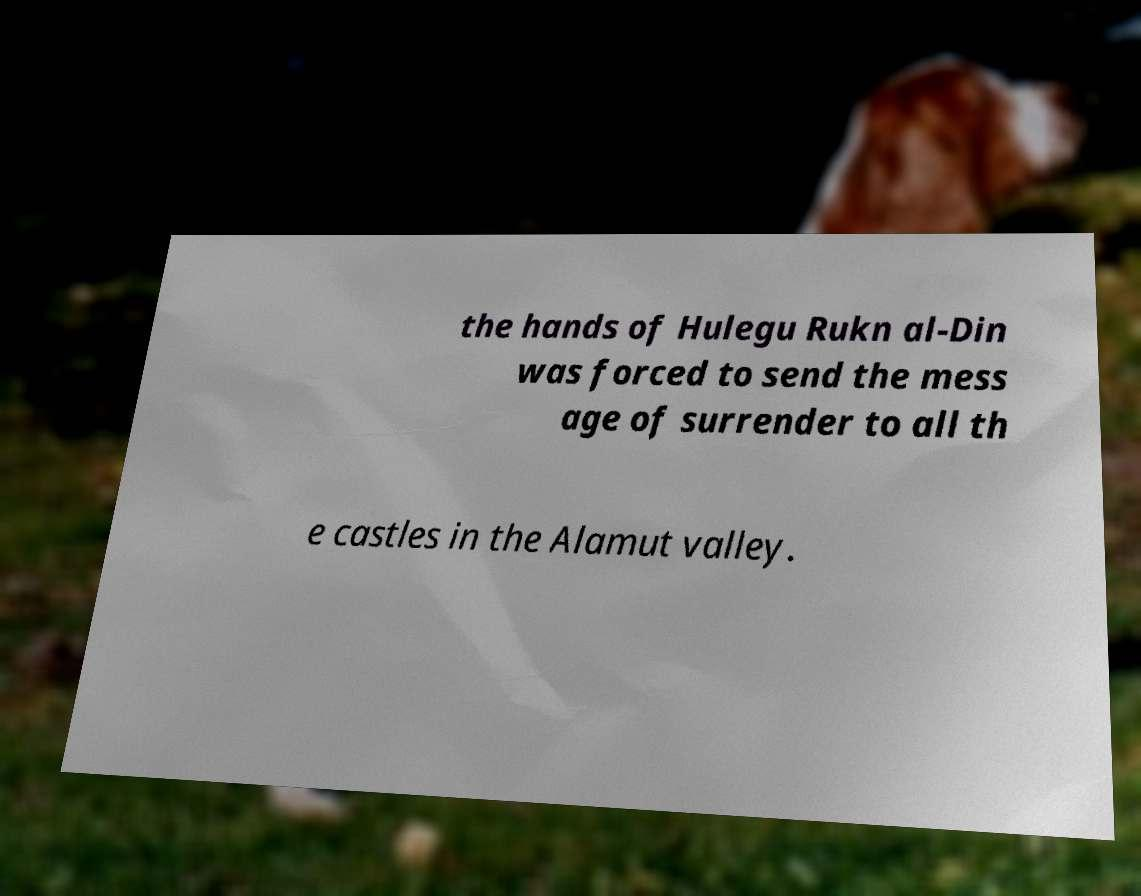Could you assist in decoding the text presented in this image and type it out clearly? the hands of Hulegu Rukn al-Din was forced to send the mess age of surrender to all th e castles in the Alamut valley. 